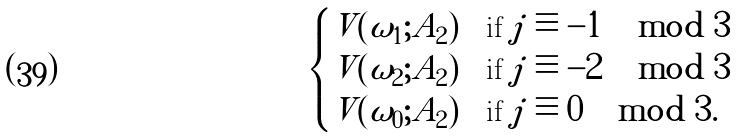Convert formula to latex. <formula><loc_0><loc_0><loc_500><loc_500>\begin{cases} V ( \omega _ { 1 } ; A _ { 2 } ) & \text {if} \ j \equiv - 1 \, \mod { 3 } \\ V ( \omega _ { 2 } ; A _ { 2 } ) & \text {if} \ j \equiv - 2 \, \mod { 3 } \\ V ( \omega _ { 0 } ; A _ { 2 } ) & \text {if} \ j \equiv 0 \, \mod { 3 } . \end{cases}</formula> 